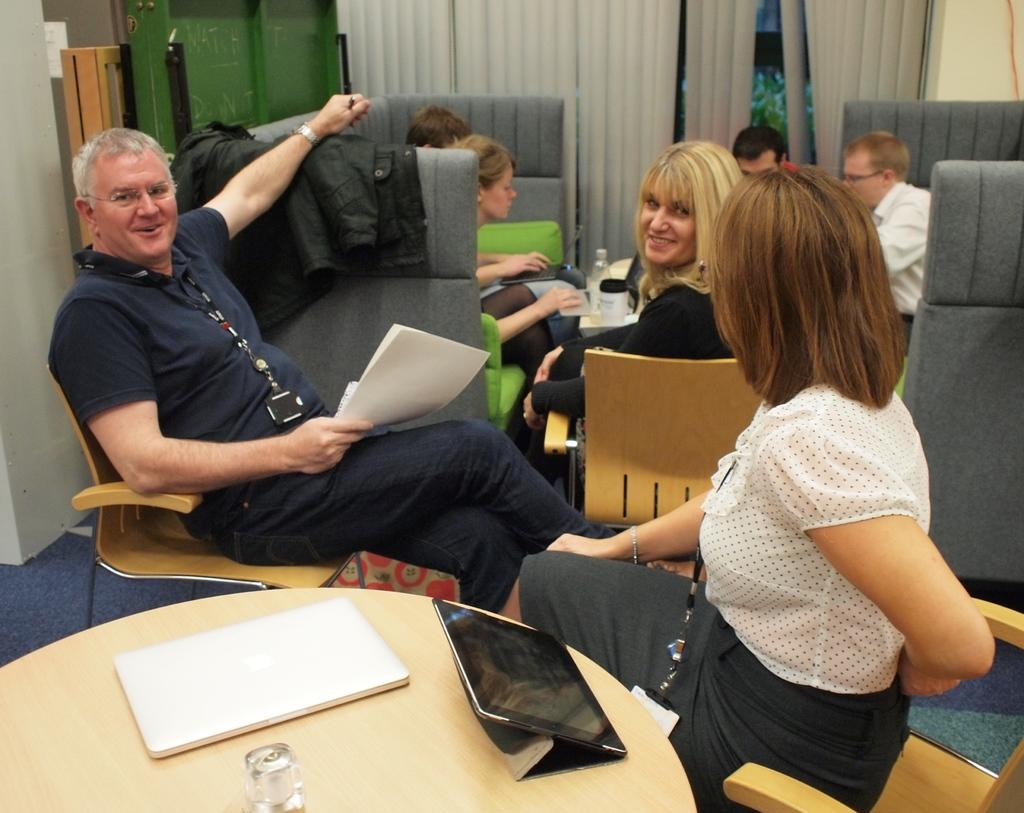How many people are present in the image? There are two people, a man and a woman, present in the image. What are the man and woman doing in the image? The man and woman are sitting in chairs. What is on the table in the image? There is a glass and a laptop on the table. What can be seen in the background of the image? There is a couch with a group of people sitting on it, a curtain, and plants in the background of the image. What type of cream is being used to mark the woman's face in the image? There is no cream or mark on the woman's face in the image. How many smiles can be seen on the man's face in the image? The image does not show the man's face, so it is not possible to determine the number of smiles on his face. 